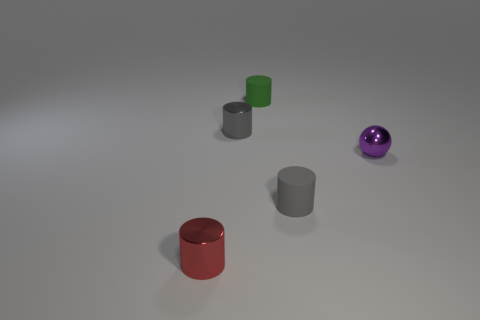There is a tiny rubber cylinder in front of the purple metal thing; what color is it?
Offer a terse response. Gray. What number of objects are either metallic cylinders that are behind the small red metallic thing or tiny cylinders that are behind the red metallic thing?
Provide a short and direct response. 3. What number of gray things are the same shape as the small purple metallic thing?
Keep it short and to the point. 0. The ball that is the same size as the green matte thing is what color?
Offer a very short reply. Purple. There is a tiny shiny cylinder that is right of the metal thing left of the small metallic cylinder that is behind the tiny red object; what color is it?
Make the answer very short. Gray. What number of things are small purple metallic balls or small rubber cylinders?
Offer a terse response. 3. Are there any other small objects made of the same material as the red thing?
Keep it short and to the point. Yes. There is a object to the right of the tiny gray cylinder in front of the small sphere; what color is it?
Your answer should be very brief. Purple. What number of cubes are brown metallic things or tiny matte objects?
Offer a very short reply. 0. There is a tiny gray rubber cylinder in front of the green cylinder; what number of small matte objects are behind it?
Keep it short and to the point. 1. 